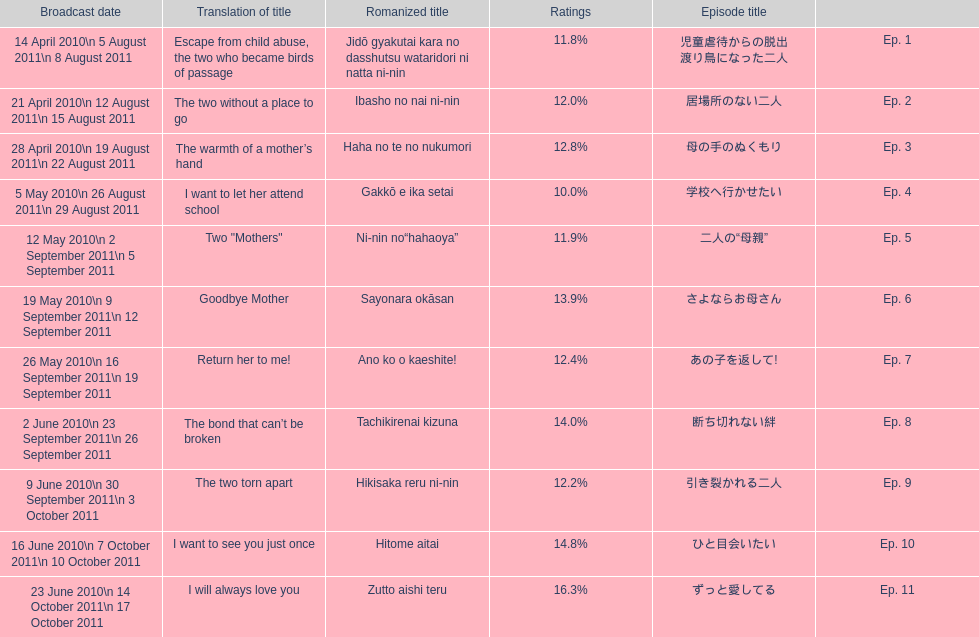What was the name of the first episode of this show? 児童虐待からの脱出 渡り鳥になった二人. 